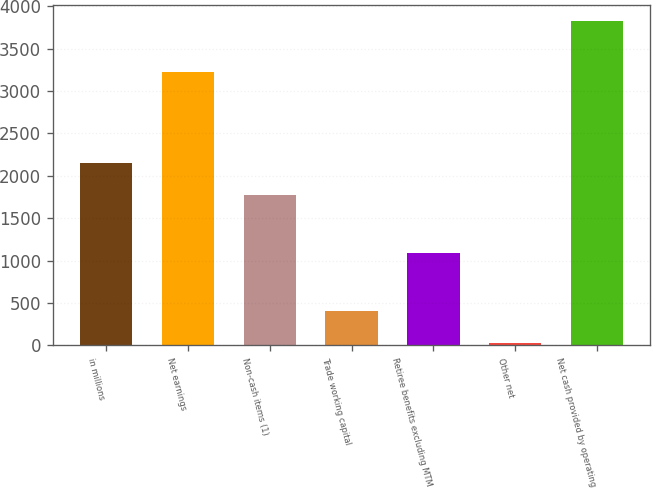Convert chart to OTSL. <chart><loc_0><loc_0><loc_500><loc_500><bar_chart><fcel>in millions<fcel>Net earnings<fcel>Non-cash items (1)<fcel>Trade working capital<fcel>Retiree benefits excluding MTM<fcel>Other net<fcel>Net cash provided by operating<nl><fcel>2154.8<fcel>3229<fcel>1775<fcel>408.8<fcel>1083<fcel>29<fcel>3827<nl></chart> 